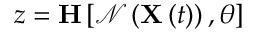Convert formula to latex. <formula><loc_0><loc_0><loc_500><loc_500>z = H \left [ \mathcal { N } \left ( X \left ( t \right ) \right ) , \theta \right ]</formula> 